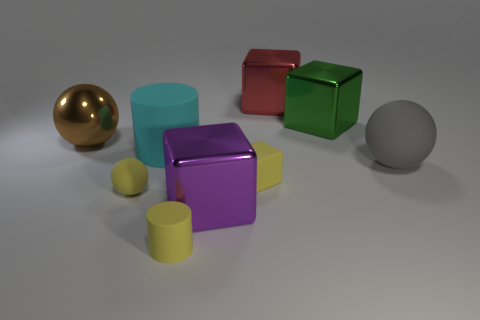Subtract 1 balls. How many balls are left? 2 Subtract all big cubes. How many cubes are left? 1 Add 1 gray spheres. How many objects exist? 10 Subtract all cyan cubes. Subtract all cyan cylinders. How many cubes are left? 4 Subtract all cubes. How many objects are left? 5 Subtract 1 yellow balls. How many objects are left? 8 Subtract all small yellow rubber blocks. Subtract all large matte balls. How many objects are left? 7 Add 6 large purple metal things. How many large purple metal things are left? 7 Add 6 tiny green metallic spheres. How many tiny green metallic spheres exist? 6 